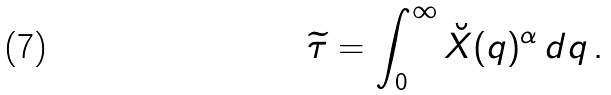Convert formula to latex. <formula><loc_0><loc_0><loc_500><loc_500>\widetilde { \tau } = \int _ { 0 } ^ { \infty } \breve { X } ( q ) ^ { \alpha } \, d q \, .</formula> 